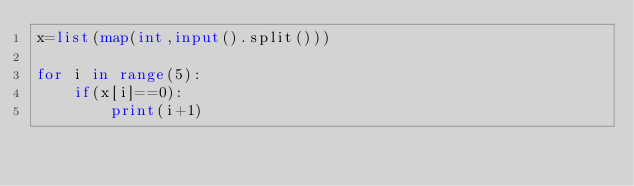<code> <loc_0><loc_0><loc_500><loc_500><_Python_>x=list(map(int,input().split()))

for i in range(5):
    if(x[i]==0):
        print(i+1)</code> 